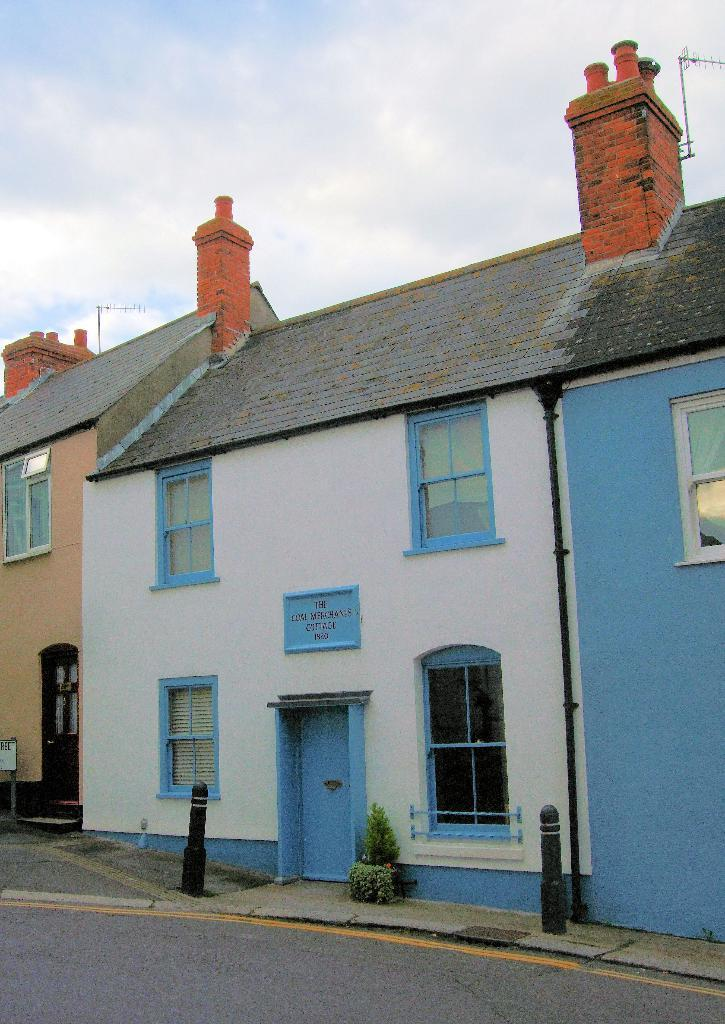What type of structures can be seen in the image? There are houses in the image. What is written or displayed on a wall in the image? There is text on a wall in the image. What type of plant is in the image? There is a plant in a pot in the image. How would you describe the sky in the image? The sky is blue and cloudy in the image. How many mice are running on the roof of the houses in the image? There are no mice present in the image; it only shows houses, text on a wall, a plant in a pot, and a blue and cloudy sky. 